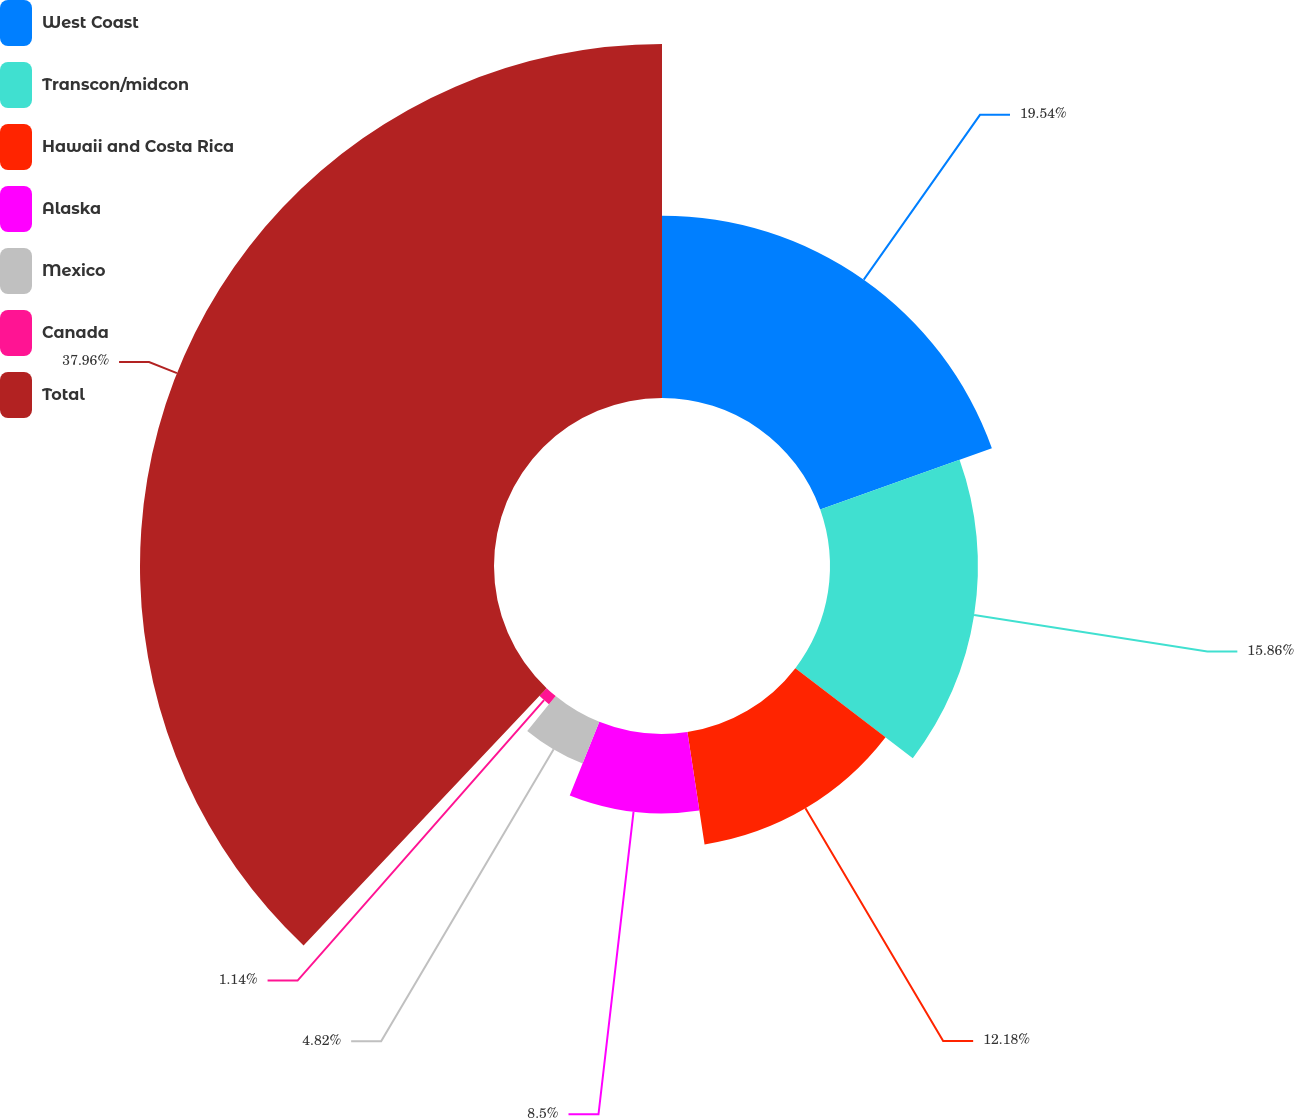Convert chart. <chart><loc_0><loc_0><loc_500><loc_500><pie_chart><fcel>West Coast<fcel>Transcon/midcon<fcel>Hawaii and Costa Rica<fcel>Alaska<fcel>Mexico<fcel>Canada<fcel>Total<nl><fcel>19.54%<fcel>15.86%<fcel>12.18%<fcel>8.5%<fcel>4.82%<fcel>1.14%<fcel>37.95%<nl></chart> 